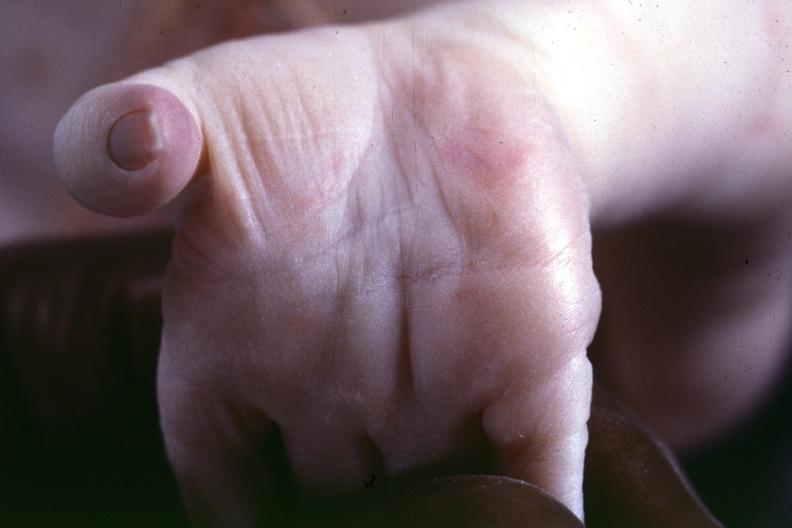re six digits and syndactyly present?
Answer the question using a single word or phrase. No 